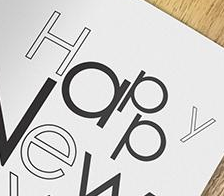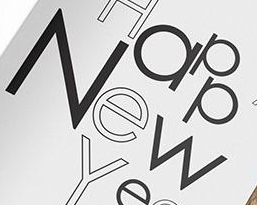Identify the words shown in these images in order, separated by a semicolon. Happy; New 